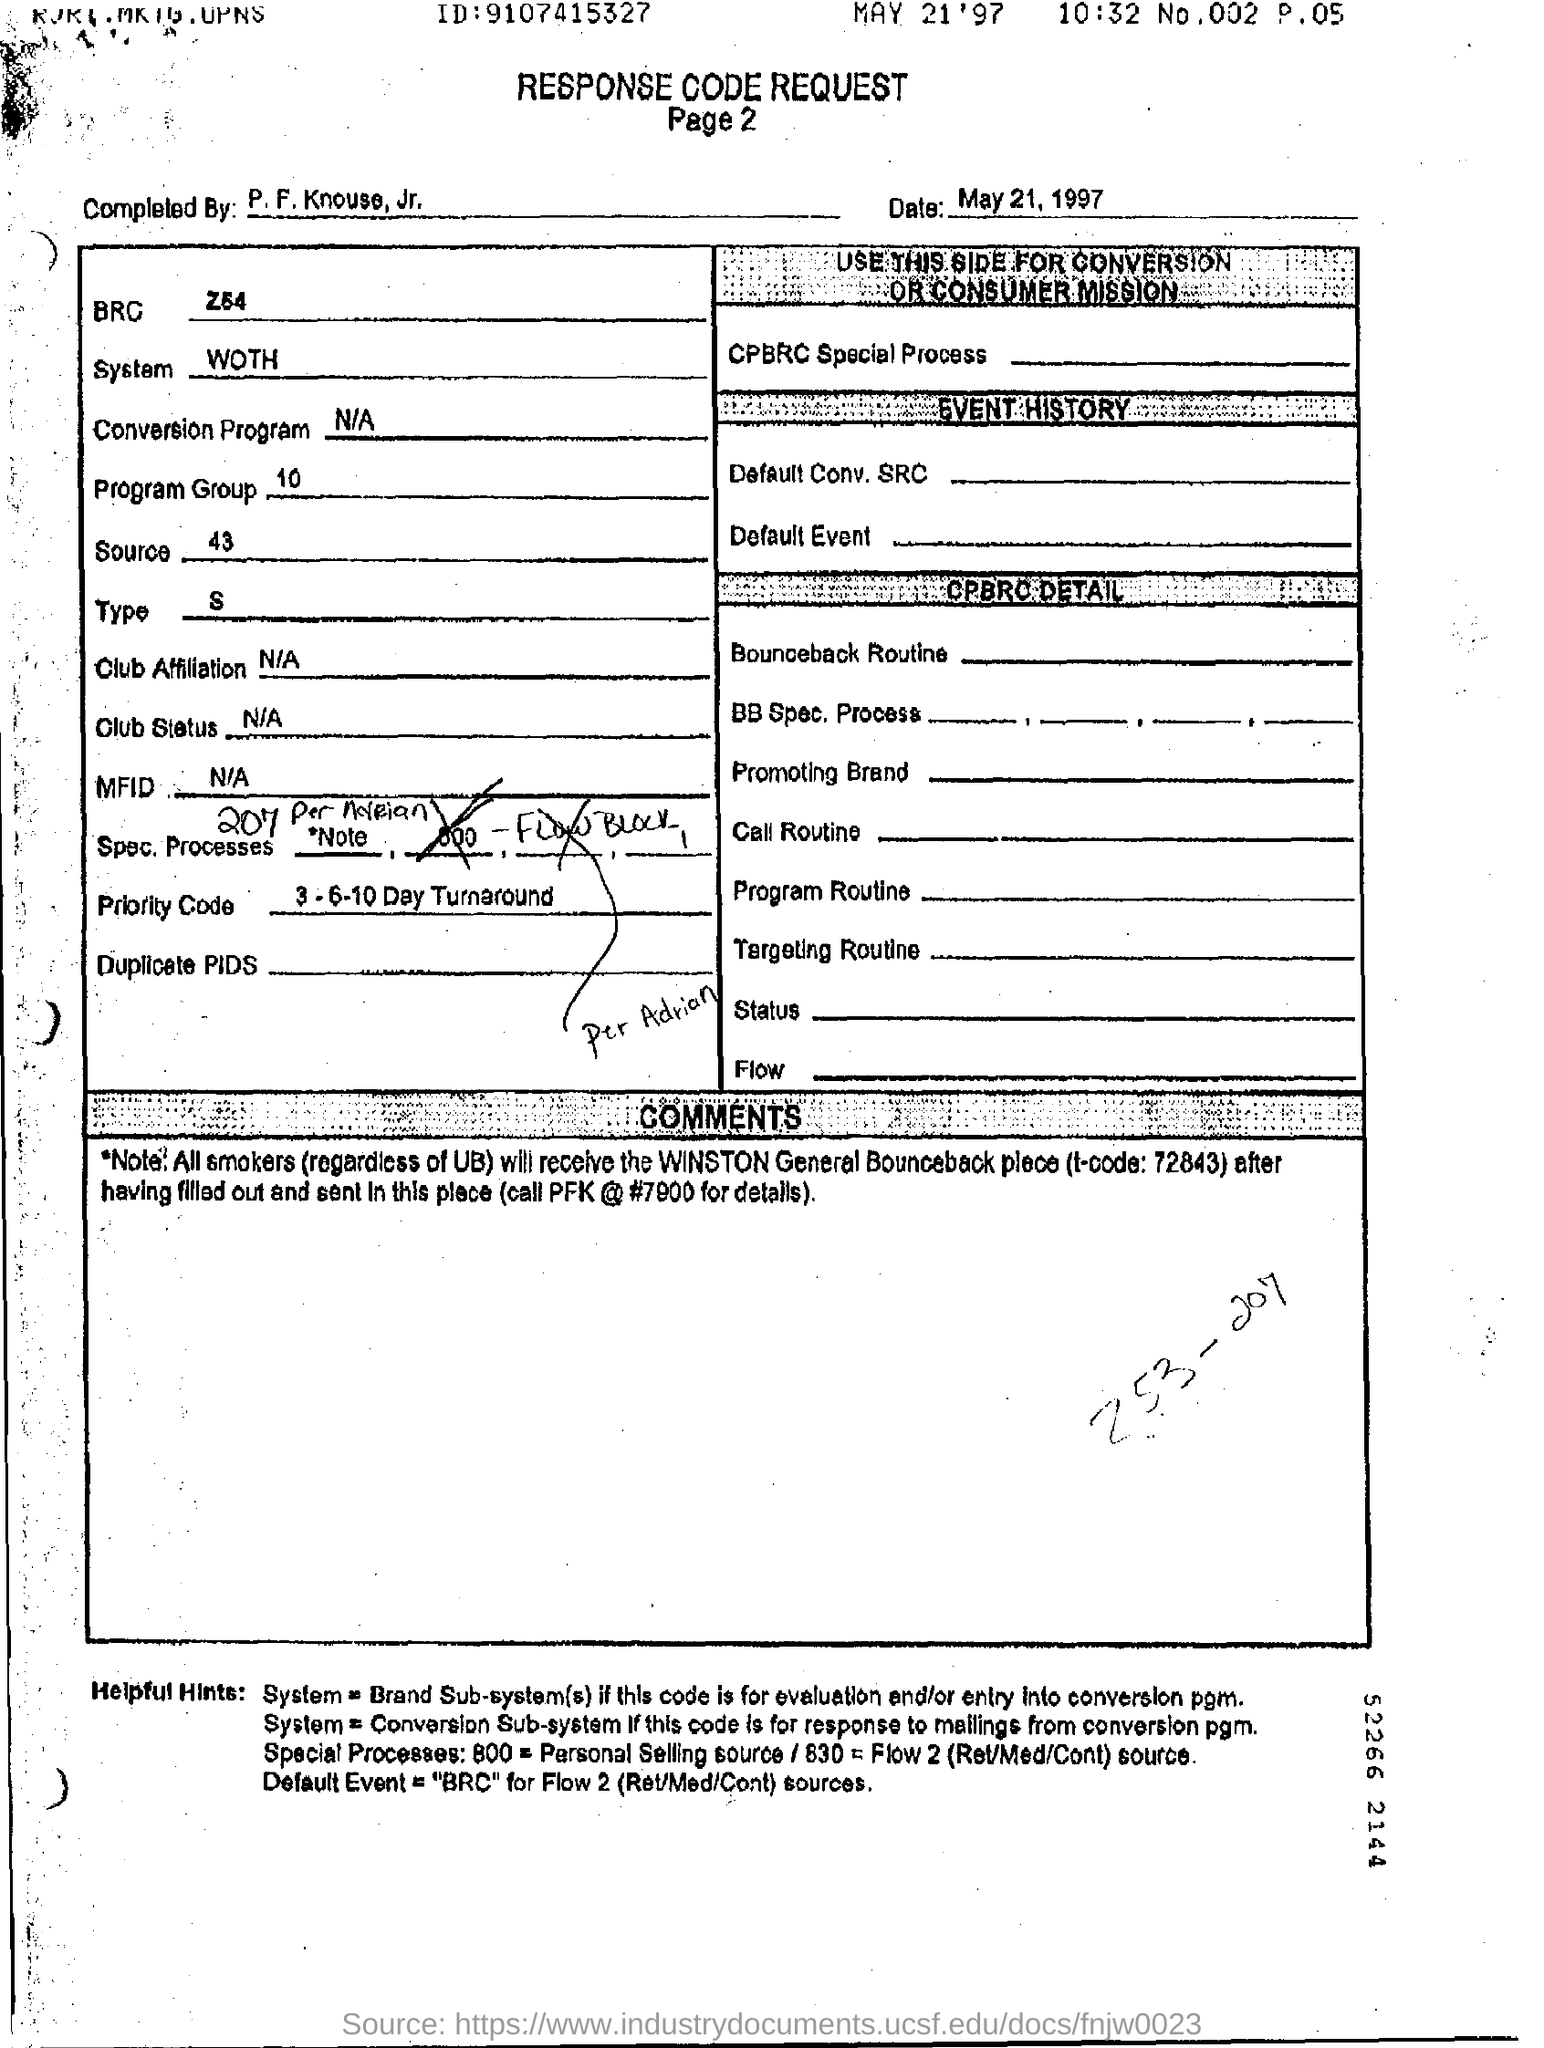List a handful of essential elements in this visual. The system referred to in the form is WOTH. The program group is a collection of instructions that executes a set of operations from 10 to... 